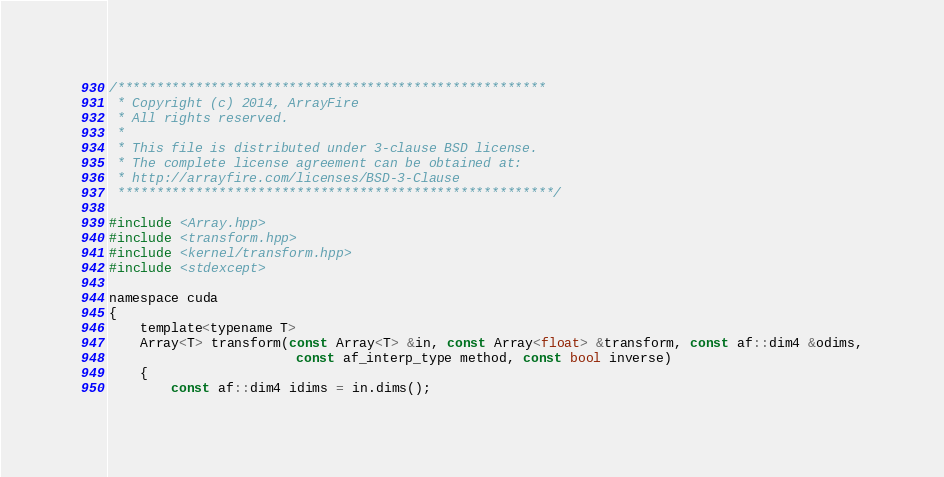<code> <loc_0><loc_0><loc_500><loc_500><_Cuda_>/*******************************************************
 * Copyright (c) 2014, ArrayFire
 * All rights reserved.
 *
 * This file is distributed under 3-clause BSD license.
 * The complete license agreement can be obtained at:
 * http://arrayfire.com/licenses/BSD-3-Clause
 ********************************************************/

#include <Array.hpp>
#include <transform.hpp>
#include <kernel/transform.hpp>
#include <stdexcept>

namespace cuda
{
    template<typename T>
    Array<T> transform(const Array<T> &in, const Array<float> &transform, const af::dim4 &odims,
                        const af_interp_type method, const bool inverse)
    {
        const af::dim4 idims = in.dims();
</code> 